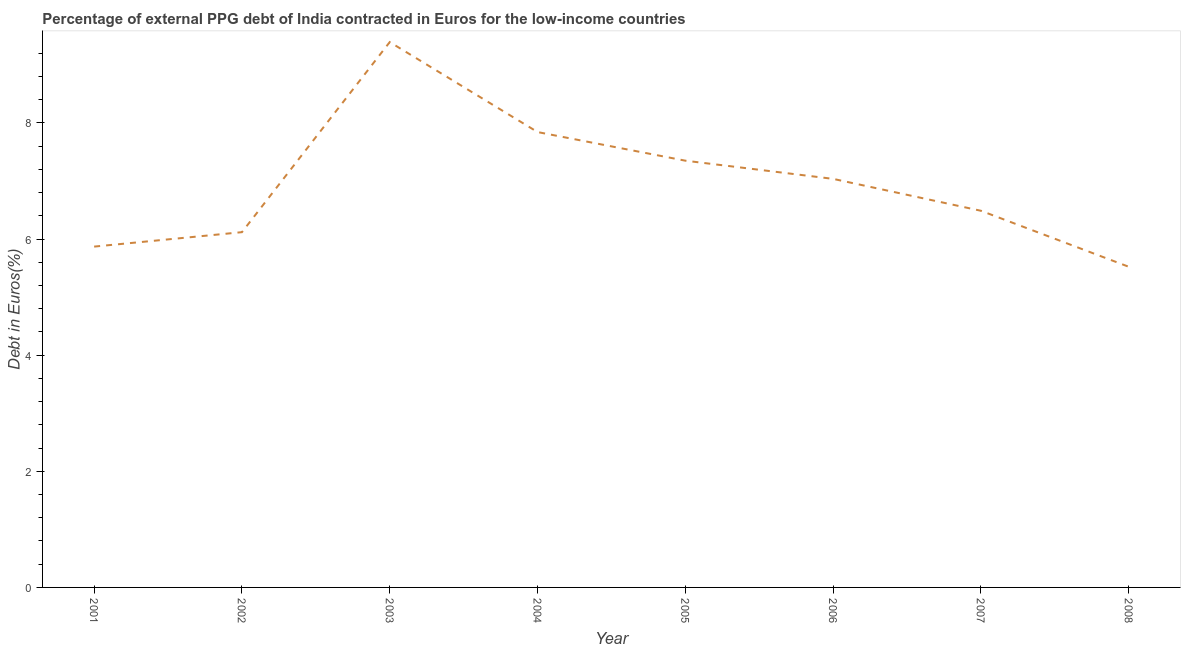What is the currency composition of ppg debt in 2007?
Your answer should be very brief. 6.49. Across all years, what is the maximum currency composition of ppg debt?
Offer a terse response. 9.39. Across all years, what is the minimum currency composition of ppg debt?
Provide a short and direct response. 5.52. What is the sum of the currency composition of ppg debt?
Ensure brevity in your answer.  55.63. What is the difference between the currency composition of ppg debt in 2004 and 2007?
Offer a very short reply. 1.36. What is the average currency composition of ppg debt per year?
Your answer should be very brief. 6.95. What is the median currency composition of ppg debt?
Give a very brief answer. 6.76. In how many years, is the currency composition of ppg debt greater than 6.8 %?
Offer a terse response. 4. What is the ratio of the currency composition of ppg debt in 2004 to that in 2006?
Offer a terse response. 1.11. What is the difference between the highest and the second highest currency composition of ppg debt?
Give a very brief answer. 1.55. What is the difference between the highest and the lowest currency composition of ppg debt?
Your answer should be compact. 3.87. Does the currency composition of ppg debt monotonically increase over the years?
Make the answer very short. No. How many lines are there?
Keep it short and to the point. 1. What is the difference between two consecutive major ticks on the Y-axis?
Provide a succinct answer. 2. What is the title of the graph?
Make the answer very short. Percentage of external PPG debt of India contracted in Euros for the low-income countries. What is the label or title of the Y-axis?
Provide a short and direct response. Debt in Euros(%). What is the Debt in Euros(%) in 2001?
Provide a short and direct response. 5.87. What is the Debt in Euros(%) of 2002?
Offer a terse response. 6.12. What is the Debt in Euros(%) of 2003?
Give a very brief answer. 9.39. What is the Debt in Euros(%) in 2004?
Give a very brief answer. 7.84. What is the Debt in Euros(%) of 2005?
Provide a succinct answer. 7.35. What is the Debt in Euros(%) in 2006?
Keep it short and to the point. 7.04. What is the Debt in Euros(%) of 2007?
Offer a terse response. 6.49. What is the Debt in Euros(%) of 2008?
Your answer should be compact. 5.52. What is the difference between the Debt in Euros(%) in 2001 and 2002?
Your answer should be compact. -0.25. What is the difference between the Debt in Euros(%) in 2001 and 2003?
Provide a succinct answer. -3.52. What is the difference between the Debt in Euros(%) in 2001 and 2004?
Offer a very short reply. -1.97. What is the difference between the Debt in Euros(%) in 2001 and 2005?
Keep it short and to the point. -1.48. What is the difference between the Debt in Euros(%) in 2001 and 2006?
Offer a terse response. -1.17. What is the difference between the Debt in Euros(%) in 2001 and 2007?
Your answer should be very brief. -0.62. What is the difference between the Debt in Euros(%) in 2001 and 2008?
Your answer should be compact. 0.35. What is the difference between the Debt in Euros(%) in 2002 and 2003?
Provide a short and direct response. -3.27. What is the difference between the Debt in Euros(%) in 2002 and 2004?
Your answer should be compact. -1.72. What is the difference between the Debt in Euros(%) in 2002 and 2005?
Keep it short and to the point. -1.23. What is the difference between the Debt in Euros(%) in 2002 and 2006?
Provide a succinct answer. -0.92. What is the difference between the Debt in Euros(%) in 2002 and 2007?
Keep it short and to the point. -0.37. What is the difference between the Debt in Euros(%) in 2002 and 2008?
Offer a very short reply. 0.6. What is the difference between the Debt in Euros(%) in 2003 and 2004?
Ensure brevity in your answer.  1.55. What is the difference between the Debt in Euros(%) in 2003 and 2005?
Provide a short and direct response. 2.04. What is the difference between the Debt in Euros(%) in 2003 and 2006?
Provide a succinct answer. 2.36. What is the difference between the Debt in Euros(%) in 2003 and 2007?
Provide a succinct answer. 2.91. What is the difference between the Debt in Euros(%) in 2003 and 2008?
Your response must be concise. 3.87. What is the difference between the Debt in Euros(%) in 2004 and 2005?
Keep it short and to the point. 0.49. What is the difference between the Debt in Euros(%) in 2004 and 2006?
Give a very brief answer. 0.81. What is the difference between the Debt in Euros(%) in 2004 and 2007?
Your answer should be compact. 1.36. What is the difference between the Debt in Euros(%) in 2004 and 2008?
Your answer should be compact. 2.32. What is the difference between the Debt in Euros(%) in 2005 and 2006?
Give a very brief answer. 0.31. What is the difference between the Debt in Euros(%) in 2005 and 2007?
Make the answer very short. 0.86. What is the difference between the Debt in Euros(%) in 2005 and 2008?
Provide a short and direct response. 1.83. What is the difference between the Debt in Euros(%) in 2006 and 2007?
Offer a very short reply. 0.55. What is the difference between the Debt in Euros(%) in 2006 and 2008?
Your answer should be compact. 1.51. What is the difference between the Debt in Euros(%) in 2007 and 2008?
Your answer should be very brief. 0.96. What is the ratio of the Debt in Euros(%) in 2001 to that in 2002?
Your answer should be compact. 0.96. What is the ratio of the Debt in Euros(%) in 2001 to that in 2004?
Your response must be concise. 0.75. What is the ratio of the Debt in Euros(%) in 2001 to that in 2005?
Provide a short and direct response. 0.8. What is the ratio of the Debt in Euros(%) in 2001 to that in 2006?
Make the answer very short. 0.83. What is the ratio of the Debt in Euros(%) in 2001 to that in 2007?
Offer a terse response. 0.91. What is the ratio of the Debt in Euros(%) in 2001 to that in 2008?
Provide a succinct answer. 1.06. What is the ratio of the Debt in Euros(%) in 2002 to that in 2003?
Offer a very short reply. 0.65. What is the ratio of the Debt in Euros(%) in 2002 to that in 2004?
Your response must be concise. 0.78. What is the ratio of the Debt in Euros(%) in 2002 to that in 2005?
Make the answer very short. 0.83. What is the ratio of the Debt in Euros(%) in 2002 to that in 2006?
Make the answer very short. 0.87. What is the ratio of the Debt in Euros(%) in 2002 to that in 2007?
Your response must be concise. 0.94. What is the ratio of the Debt in Euros(%) in 2002 to that in 2008?
Your response must be concise. 1.11. What is the ratio of the Debt in Euros(%) in 2003 to that in 2004?
Provide a succinct answer. 1.2. What is the ratio of the Debt in Euros(%) in 2003 to that in 2005?
Give a very brief answer. 1.28. What is the ratio of the Debt in Euros(%) in 2003 to that in 2006?
Make the answer very short. 1.33. What is the ratio of the Debt in Euros(%) in 2003 to that in 2007?
Make the answer very short. 1.45. What is the ratio of the Debt in Euros(%) in 2003 to that in 2008?
Your answer should be very brief. 1.7. What is the ratio of the Debt in Euros(%) in 2004 to that in 2005?
Your answer should be very brief. 1.07. What is the ratio of the Debt in Euros(%) in 2004 to that in 2006?
Provide a short and direct response. 1.11. What is the ratio of the Debt in Euros(%) in 2004 to that in 2007?
Provide a short and direct response. 1.21. What is the ratio of the Debt in Euros(%) in 2004 to that in 2008?
Make the answer very short. 1.42. What is the ratio of the Debt in Euros(%) in 2005 to that in 2006?
Your answer should be very brief. 1.04. What is the ratio of the Debt in Euros(%) in 2005 to that in 2007?
Provide a short and direct response. 1.13. What is the ratio of the Debt in Euros(%) in 2005 to that in 2008?
Give a very brief answer. 1.33. What is the ratio of the Debt in Euros(%) in 2006 to that in 2007?
Your answer should be compact. 1.08. What is the ratio of the Debt in Euros(%) in 2006 to that in 2008?
Provide a succinct answer. 1.27. What is the ratio of the Debt in Euros(%) in 2007 to that in 2008?
Provide a succinct answer. 1.18. 